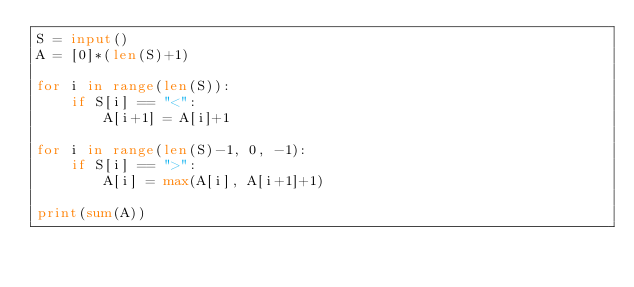<code> <loc_0><loc_0><loc_500><loc_500><_Python_>S = input()
A = [0]*(len(S)+1)

for i in range(len(S)):
    if S[i] == "<":
        A[i+1] = A[i]+1

for i in range(len(S)-1, 0, -1):
    if S[i] == ">":
        A[i] = max(A[i], A[i+1]+1)

print(sum(A))</code> 